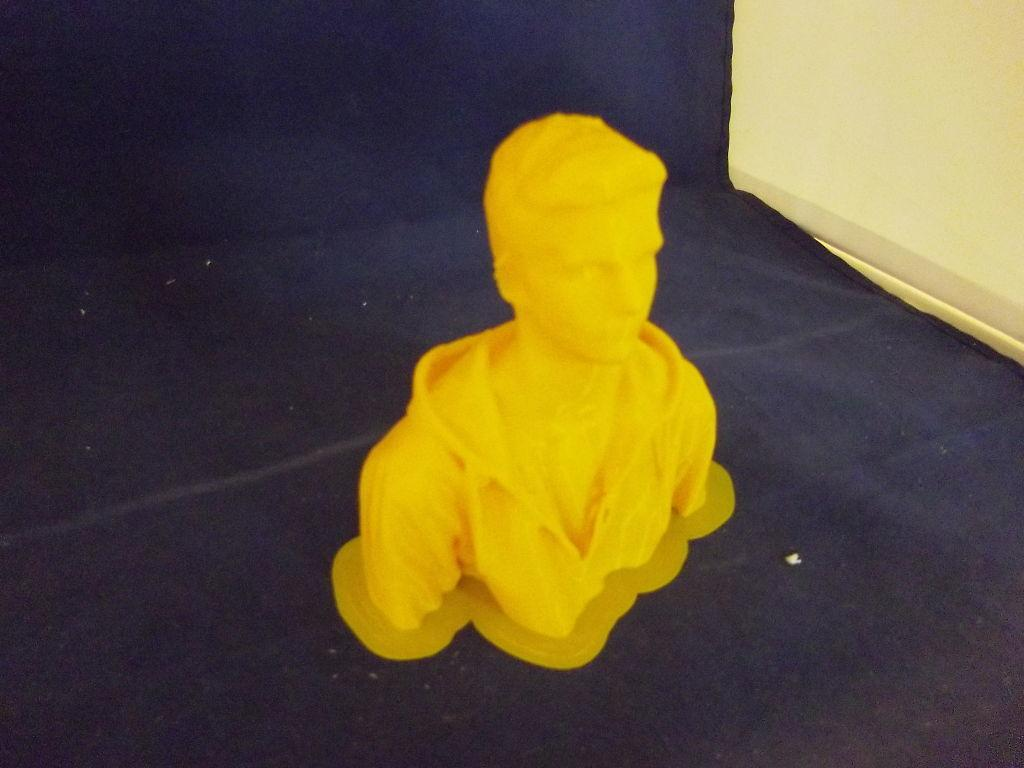What is the main subject in the center of the image? There is a statue in the center of the image. What is the statue resting on? The statue is placed on a surface. What can be seen on the right side of the image? There is a wall on the right side of the image. What type of loaf is being sold at the market in the image? There is no market or loaf present in the image; it features a statue placed on a surface with a wall on the right side. 